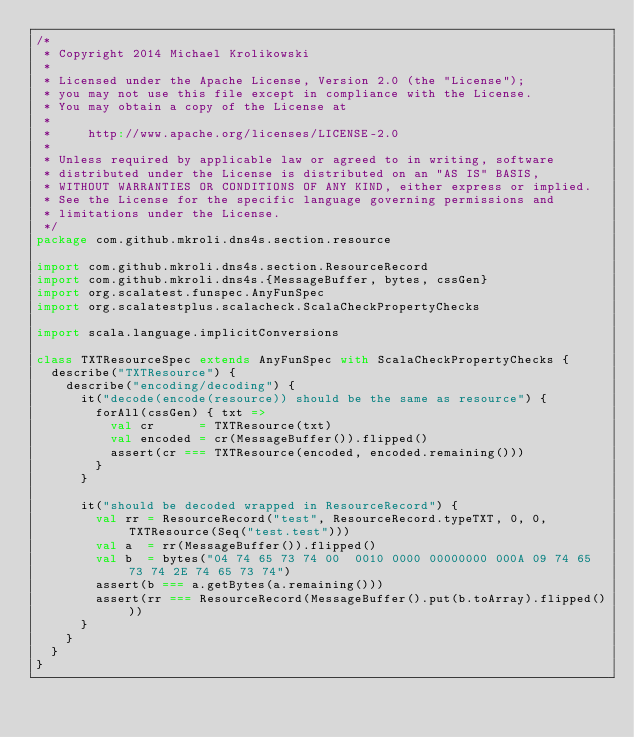Convert code to text. <code><loc_0><loc_0><loc_500><loc_500><_Scala_>/*
 * Copyright 2014 Michael Krolikowski
 *
 * Licensed under the Apache License, Version 2.0 (the "License");
 * you may not use this file except in compliance with the License.
 * You may obtain a copy of the License at
 *
 *     http://www.apache.org/licenses/LICENSE-2.0
 *
 * Unless required by applicable law or agreed to in writing, software
 * distributed under the License is distributed on an "AS IS" BASIS,
 * WITHOUT WARRANTIES OR CONDITIONS OF ANY KIND, either express or implied.
 * See the License for the specific language governing permissions and
 * limitations under the License.
 */
package com.github.mkroli.dns4s.section.resource

import com.github.mkroli.dns4s.section.ResourceRecord
import com.github.mkroli.dns4s.{MessageBuffer, bytes, cssGen}
import org.scalatest.funspec.AnyFunSpec
import org.scalatestplus.scalacheck.ScalaCheckPropertyChecks

import scala.language.implicitConversions

class TXTResourceSpec extends AnyFunSpec with ScalaCheckPropertyChecks {
  describe("TXTResource") {
    describe("encoding/decoding") {
      it("decode(encode(resource)) should be the same as resource") {
        forAll(cssGen) { txt =>
          val cr      = TXTResource(txt)
          val encoded = cr(MessageBuffer()).flipped()
          assert(cr === TXTResource(encoded, encoded.remaining()))
        }
      }

      it("should be decoded wrapped in ResourceRecord") {
        val rr = ResourceRecord("test", ResourceRecord.typeTXT, 0, 0, TXTResource(Seq("test.test")))
        val a  = rr(MessageBuffer()).flipped()
        val b  = bytes("04 74 65 73 74 00  0010 0000 00000000 000A 09 74 65 73 74 2E 74 65 73 74")
        assert(b === a.getBytes(a.remaining()))
        assert(rr === ResourceRecord(MessageBuffer().put(b.toArray).flipped()))
      }
    }
  }
}
</code> 